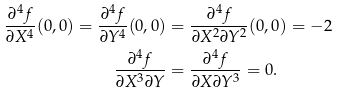Convert formula to latex. <formula><loc_0><loc_0><loc_500><loc_500>\frac { \partial ^ { 4 } f } { \partial X ^ { 4 } } ( 0 , 0 ) = \frac { \partial ^ { 4 } f } { \partial Y ^ { 4 } } ( 0 , 0 ) & = \frac { \partial ^ { 4 } f } { \partial X ^ { 2 } \partial Y ^ { 2 } } ( 0 , 0 ) = - 2 \\ \frac { \partial ^ { 4 } f } { \partial X ^ { 3 } \partial Y } & = \frac { \partial ^ { 4 } f } { \partial X \partial Y ^ { 3 } } = 0 .</formula> 